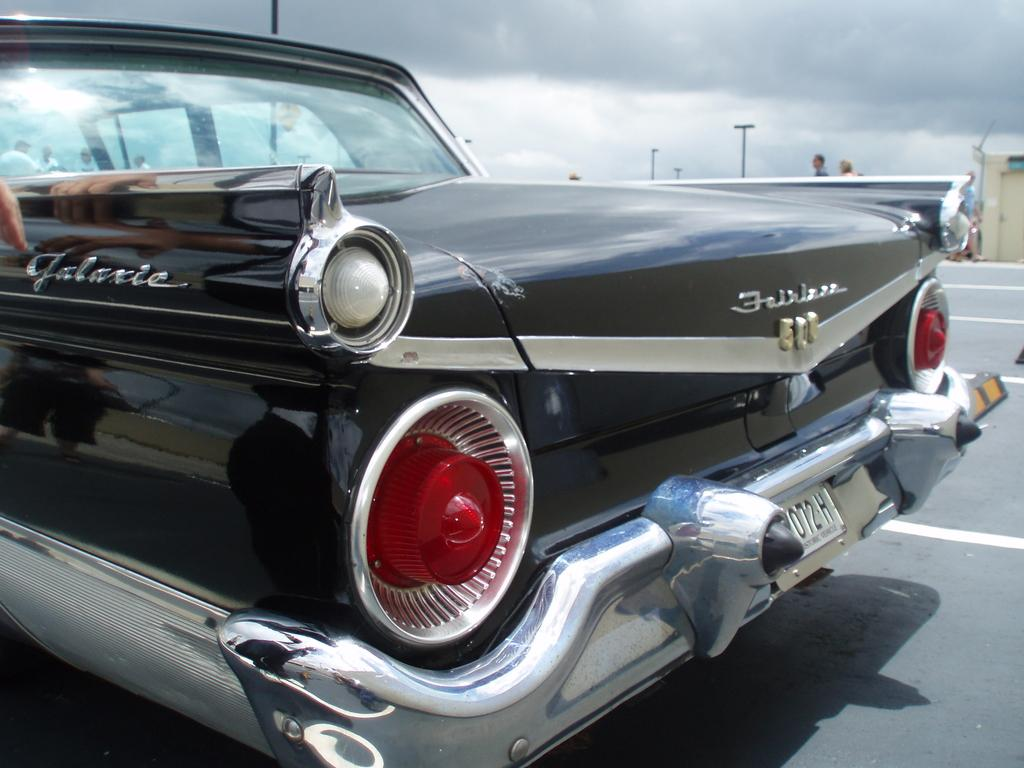What is the main subject of the image? The main subject of the image is a car on the road. Are there any people visible in the image? Yes, there are people behind the car. What else can be seen in the image besides the car and people? There are poles in the image. What is visible in the background of the image? There are clouds in the sky in the background of the image. What type of pot is being used by the family in the image? There is no family or pot present in the image; it features a car on the road with people behind it and poles in the background. 